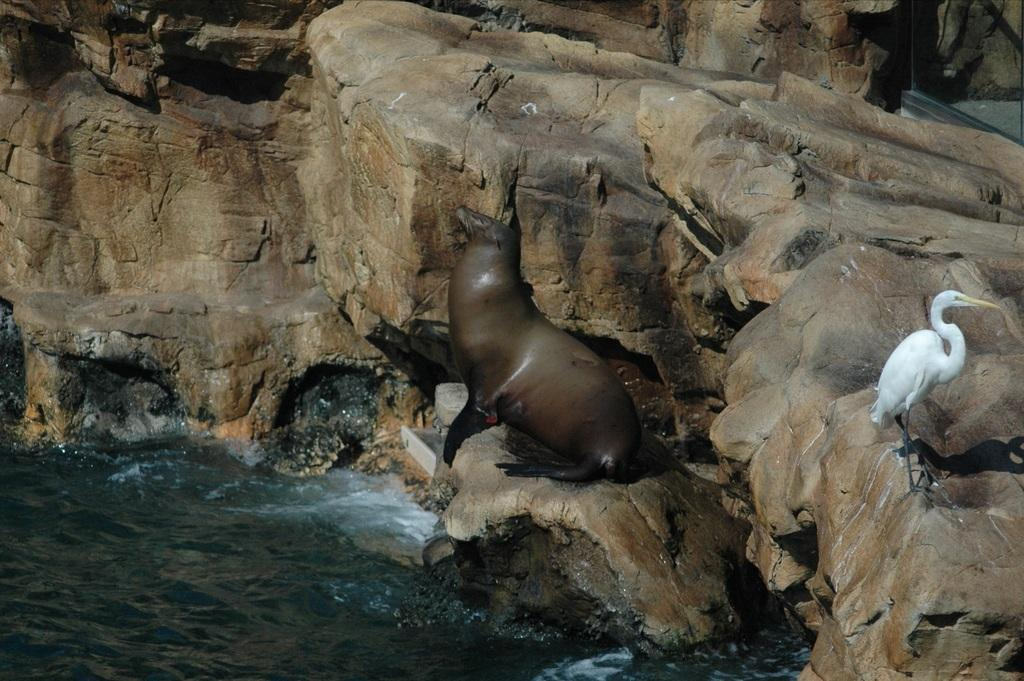What animals can be seen in the foreground of the image? There is a sea lion and a crane in the foreground of the image. Where are the sea lion and crane located? They are on a rock in the image. What can be seen at the bottom of the image? There is water visible at the bottom of the image. What type of sweater is the frog wearing in the image? There is no frog present in the image, and therefore no sweater can be observed. 